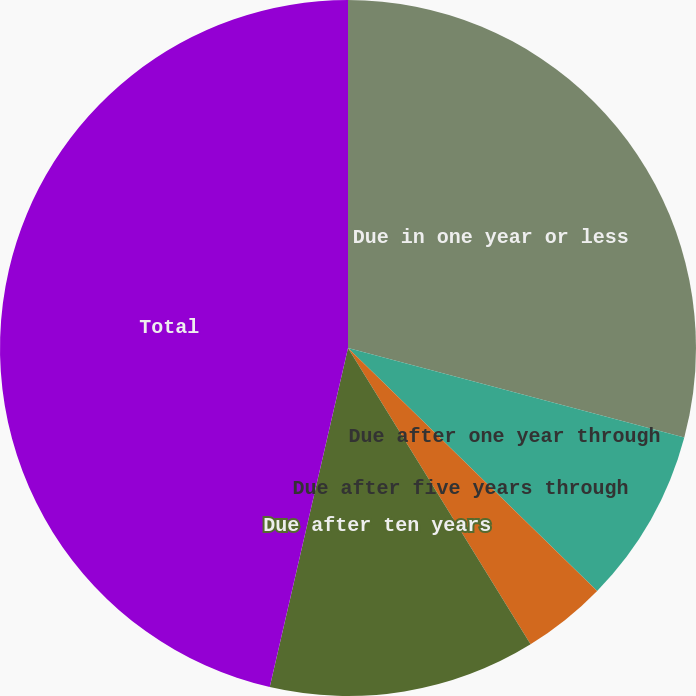Convert chart to OTSL. <chart><loc_0><loc_0><loc_500><loc_500><pie_chart><fcel>Due in one year or less<fcel>Due after one year through<fcel>Due after five years through<fcel>Due after ten years<fcel>Total<nl><fcel>29.14%<fcel>8.16%<fcel>3.91%<fcel>12.4%<fcel>46.39%<nl></chart> 